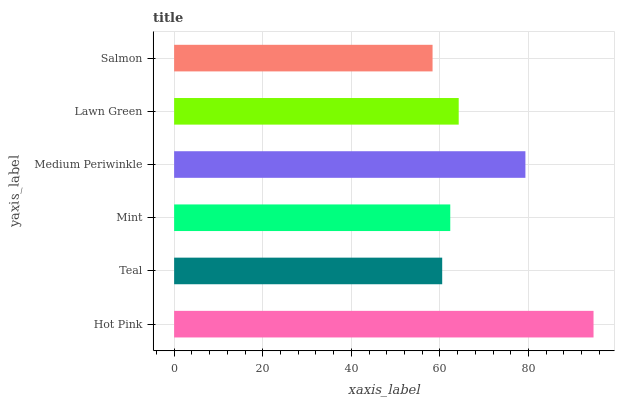Is Salmon the minimum?
Answer yes or no. Yes. Is Hot Pink the maximum?
Answer yes or no. Yes. Is Teal the minimum?
Answer yes or no. No. Is Teal the maximum?
Answer yes or no. No. Is Hot Pink greater than Teal?
Answer yes or no. Yes. Is Teal less than Hot Pink?
Answer yes or no. Yes. Is Teal greater than Hot Pink?
Answer yes or no. No. Is Hot Pink less than Teal?
Answer yes or no. No. Is Lawn Green the high median?
Answer yes or no. Yes. Is Mint the low median?
Answer yes or no. Yes. Is Teal the high median?
Answer yes or no. No. Is Medium Periwinkle the low median?
Answer yes or no. No. 